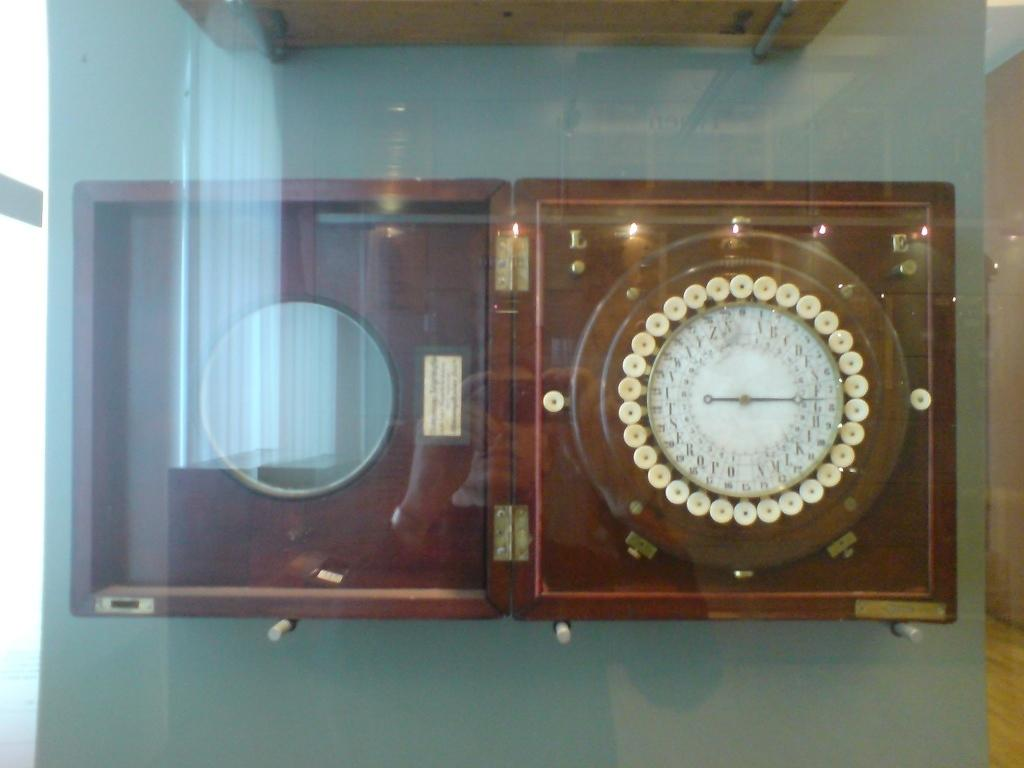What object in the image can be used to tell time? There is a clock in the image that can be used to tell time. What is the color of the surface to which the clock is attached? The clock is attached to a gray color surface. What is placed in front of the clock? There is a glass in front of the clock. How many chairs are visible in the scene? There are no chairs visible in the image. What type of party is taking place in the image? There is no party depicted in the image; it only features a clock, a gray surface, and a glass. 